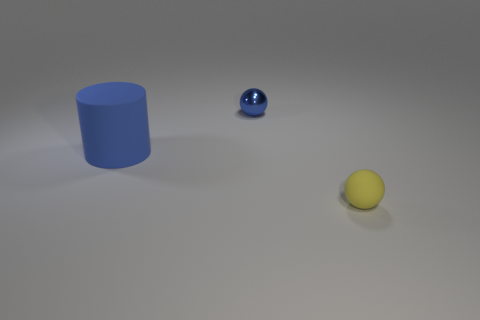Add 3 small green rubber spheres. How many objects exist? 6 Subtract all spheres. How many objects are left? 1 Add 1 small rubber objects. How many small rubber objects are left? 2 Add 2 yellow rubber things. How many yellow rubber things exist? 3 Subtract 0 green balls. How many objects are left? 3 Subtract all yellow balls. Subtract all tiny blue shiny spheres. How many objects are left? 1 